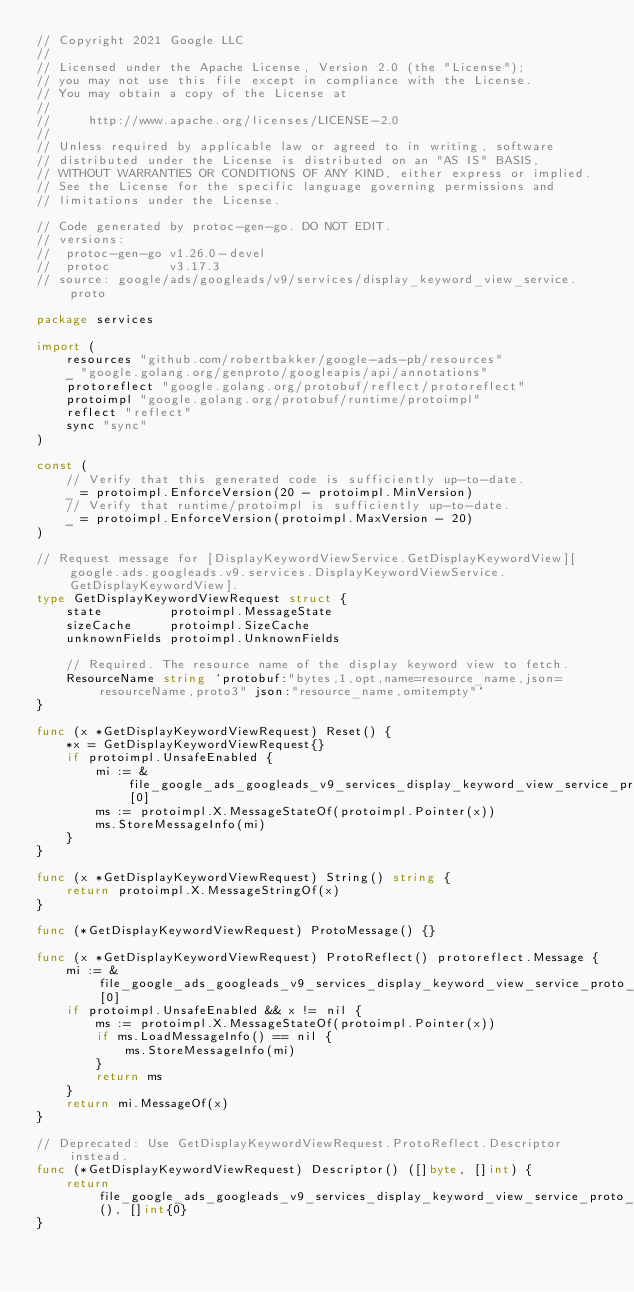<code> <loc_0><loc_0><loc_500><loc_500><_Go_>// Copyright 2021 Google LLC
//
// Licensed under the Apache License, Version 2.0 (the "License");
// you may not use this file except in compliance with the License.
// You may obtain a copy of the License at
//
//     http://www.apache.org/licenses/LICENSE-2.0
//
// Unless required by applicable law or agreed to in writing, software
// distributed under the License is distributed on an "AS IS" BASIS,
// WITHOUT WARRANTIES OR CONDITIONS OF ANY KIND, either express or implied.
// See the License for the specific language governing permissions and
// limitations under the License.

// Code generated by protoc-gen-go. DO NOT EDIT.
// versions:
// 	protoc-gen-go v1.26.0-devel
// 	protoc        v3.17.3
// source: google/ads/googleads/v9/services/display_keyword_view_service.proto

package services

import (
	resources "github.com/robertbakker/google-ads-pb/resources"
	_ "google.golang.org/genproto/googleapis/api/annotations"
	protoreflect "google.golang.org/protobuf/reflect/protoreflect"
	protoimpl "google.golang.org/protobuf/runtime/protoimpl"
	reflect "reflect"
	sync "sync"
)

const (
	// Verify that this generated code is sufficiently up-to-date.
	_ = protoimpl.EnforceVersion(20 - protoimpl.MinVersion)
	// Verify that runtime/protoimpl is sufficiently up-to-date.
	_ = protoimpl.EnforceVersion(protoimpl.MaxVersion - 20)
)

// Request message for [DisplayKeywordViewService.GetDisplayKeywordView][google.ads.googleads.v9.services.DisplayKeywordViewService.GetDisplayKeywordView].
type GetDisplayKeywordViewRequest struct {
	state         protoimpl.MessageState
	sizeCache     protoimpl.SizeCache
	unknownFields protoimpl.UnknownFields

	// Required. The resource name of the display keyword view to fetch.
	ResourceName string `protobuf:"bytes,1,opt,name=resource_name,json=resourceName,proto3" json:"resource_name,omitempty"`
}

func (x *GetDisplayKeywordViewRequest) Reset() {
	*x = GetDisplayKeywordViewRequest{}
	if protoimpl.UnsafeEnabled {
		mi := &file_google_ads_googleads_v9_services_display_keyword_view_service_proto_msgTypes[0]
		ms := protoimpl.X.MessageStateOf(protoimpl.Pointer(x))
		ms.StoreMessageInfo(mi)
	}
}

func (x *GetDisplayKeywordViewRequest) String() string {
	return protoimpl.X.MessageStringOf(x)
}

func (*GetDisplayKeywordViewRequest) ProtoMessage() {}

func (x *GetDisplayKeywordViewRequest) ProtoReflect() protoreflect.Message {
	mi := &file_google_ads_googleads_v9_services_display_keyword_view_service_proto_msgTypes[0]
	if protoimpl.UnsafeEnabled && x != nil {
		ms := protoimpl.X.MessageStateOf(protoimpl.Pointer(x))
		if ms.LoadMessageInfo() == nil {
			ms.StoreMessageInfo(mi)
		}
		return ms
	}
	return mi.MessageOf(x)
}

// Deprecated: Use GetDisplayKeywordViewRequest.ProtoReflect.Descriptor instead.
func (*GetDisplayKeywordViewRequest) Descriptor() ([]byte, []int) {
	return file_google_ads_googleads_v9_services_display_keyword_view_service_proto_rawDescGZIP(), []int{0}
}
</code> 